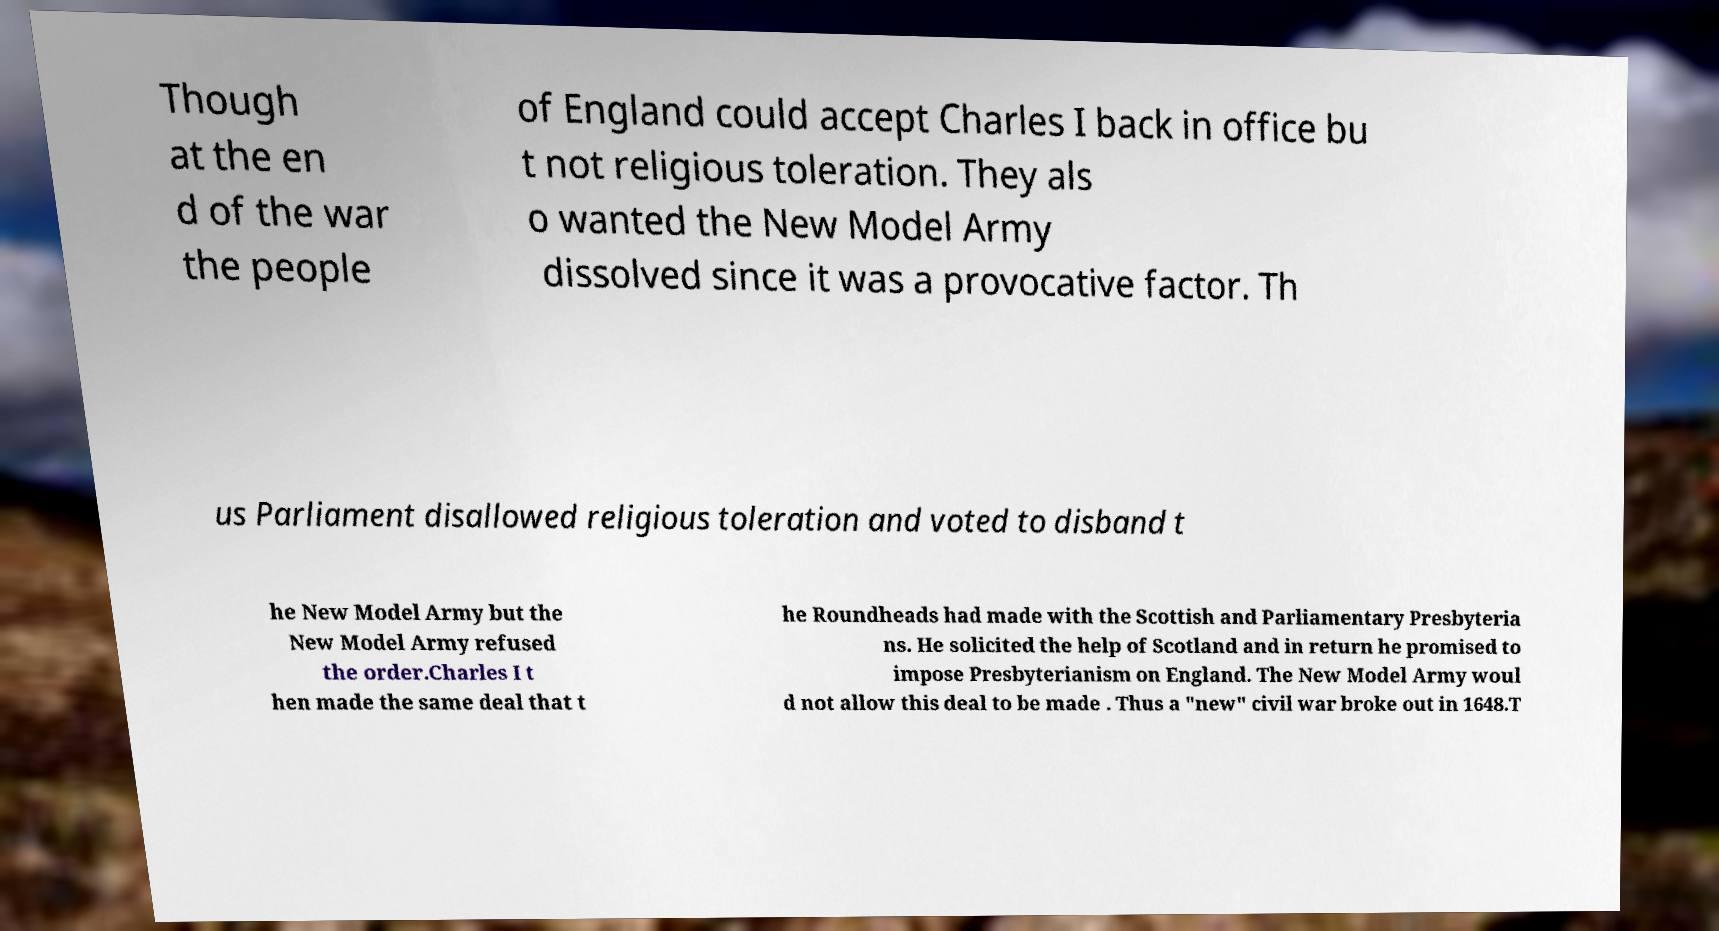Could you assist in decoding the text presented in this image and type it out clearly? Though at the en d of the war the people of England could accept Charles I back in office bu t not religious toleration. They als o wanted the New Model Army dissolved since it was a provocative factor. Th us Parliament disallowed religious toleration and voted to disband t he New Model Army but the New Model Army refused the order.Charles I t hen made the same deal that t he Roundheads had made with the Scottish and Parliamentary Presbyteria ns. He solicited the help of Scotland and in return he promised to impose Presbyterianism on England. The New Model Army woul d not allow this deal to be made . Thus a "new" civil war broke out in 1648.T 